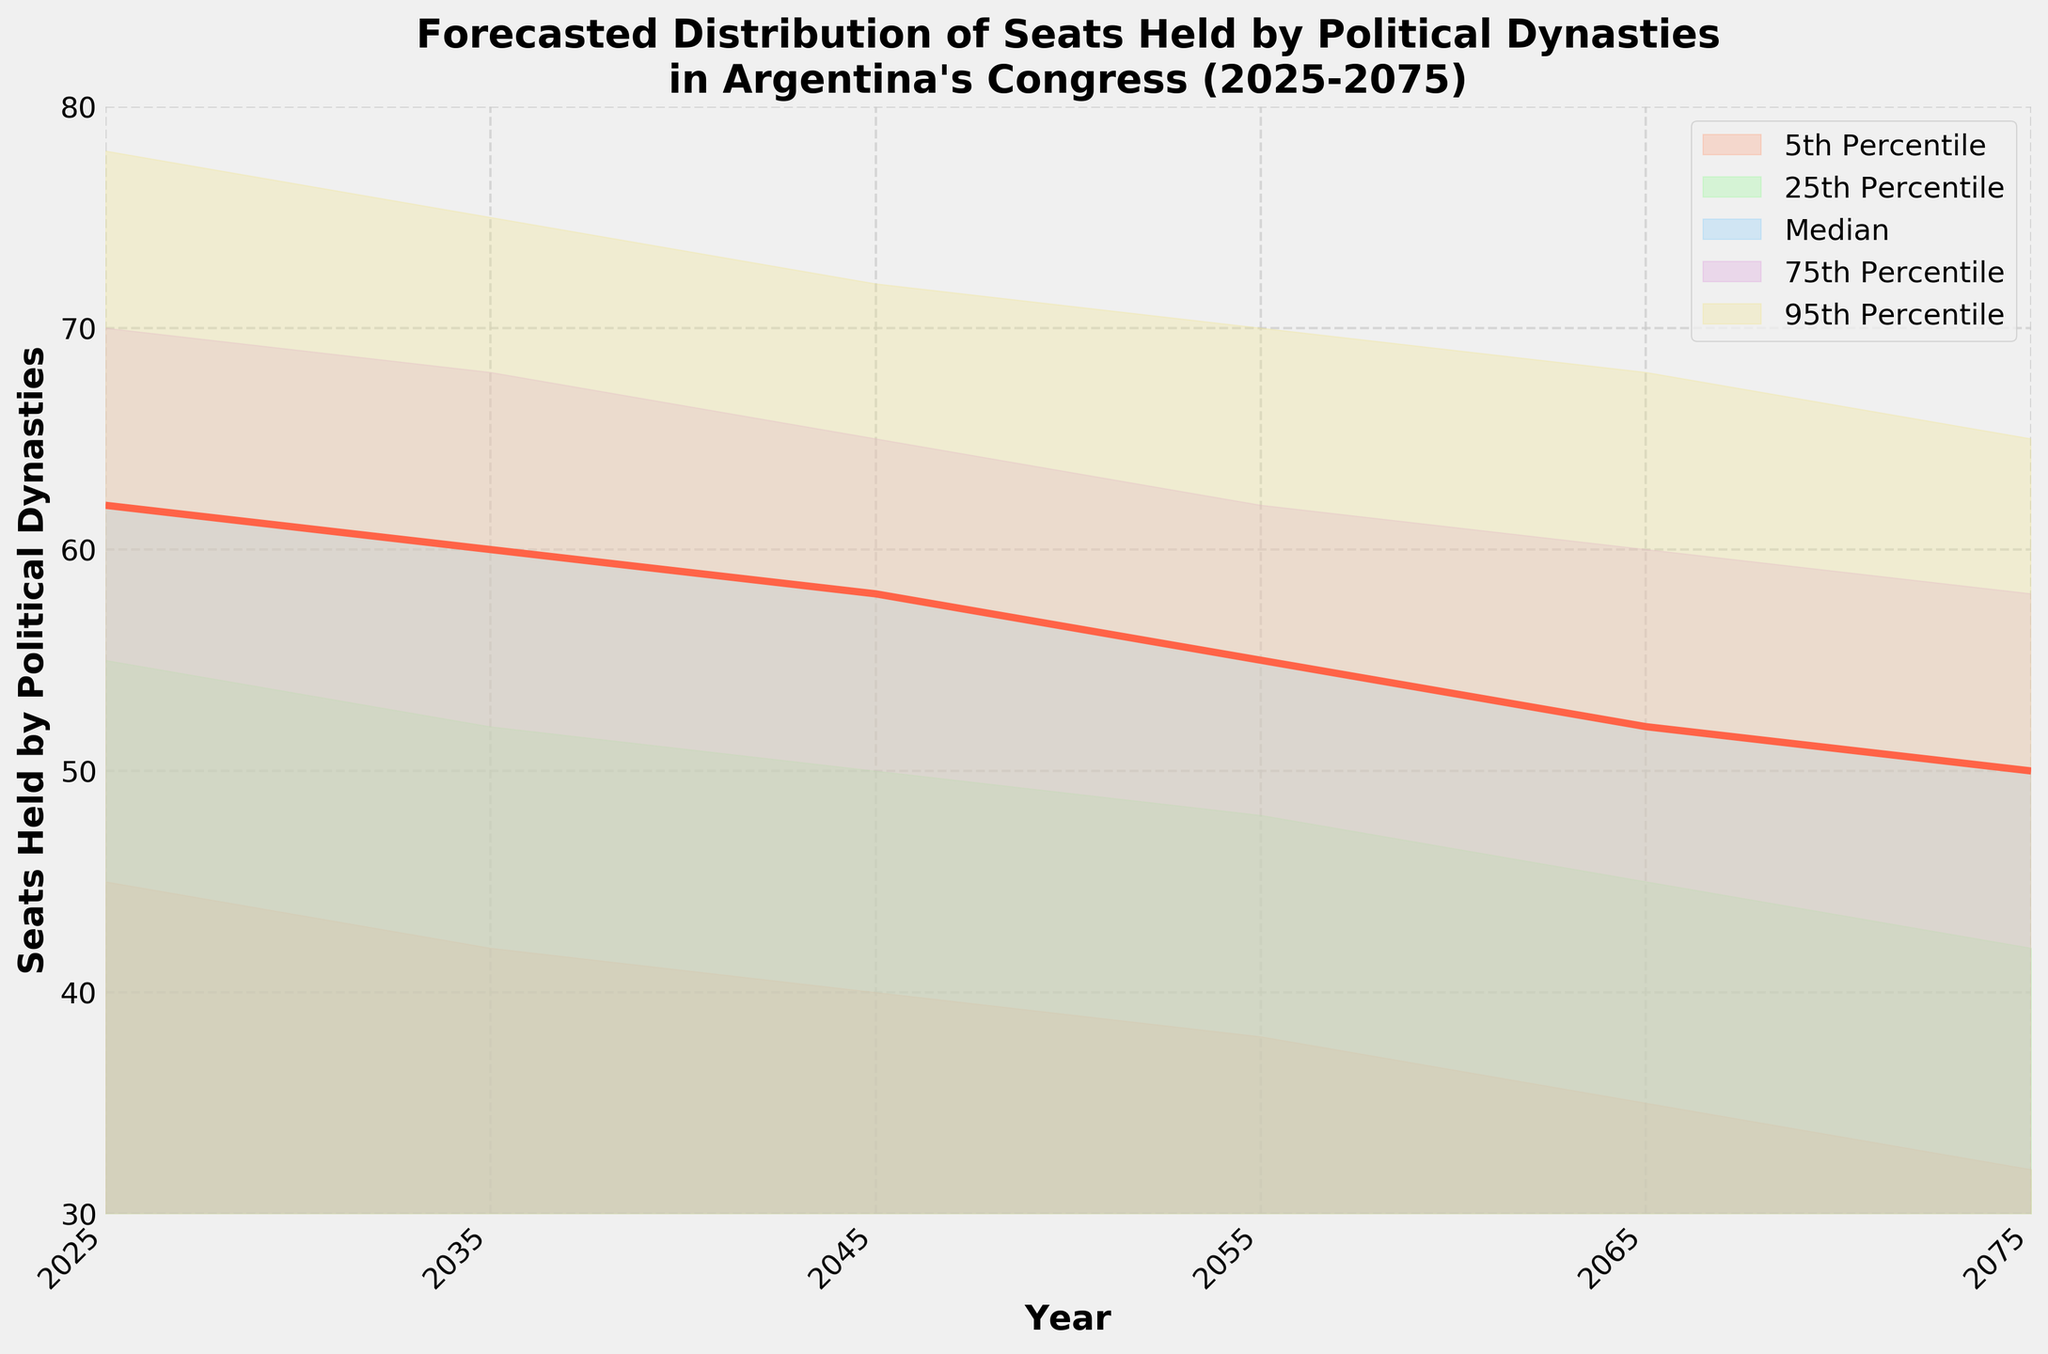What is the title of the figure? The title is usually located at the top of the plot and describes the content being presented. Here, the title shows that the figure is about projecting the number of seats held by political dynasties in Argentina's Congress over several decades.
Answer: Forecasted Distribution of Seats Held by Political Dynasties in Argentina's Congress (2025-2075) What does the y-axis represent? The y-axis typically represents the measurement being plotted. In this figure, it represents the number of seats held by political dynasties in Argentina's Congress.
Answer: Seats Held by Political Dynasties Which color is used to represent the median forecast? In the figure, the median forecast is depicted by a specific color to differentiate it from other percentiles. Here, it is shown in red, making it easy to identify.
Answer: Red What is the median number of seats predicted for the year 2045? The median line provides the central forecast for each year. To find the median number of seats for 2045, locate the median line on the y-axis corresponding to the year 2045.
Answer: 58 How does the range between the 5th and 95th percentiles change from 2025 to 2075? To determine the range, subtract the 5th percentile value from the 95th percentile value for each year and then compare these ranges.
Answer: It decreases from 33 to 33 seats In which year is the median number of seats forecasted to be 52? Look for the year where the median forecast (red line) intersects with the y-axis value of 52 seats.
Answer: 2065 By how much does the median forecast change between 2025 and 2075? Subtract the median value for 2075 from that for 2025 to find the difference.
Answer: 12 seats decrease How does the forecasted number of seats at the 25th percentile compare between 2035 and 2045? Compare the 25th percentile values for the two years by checking the corresponding y-axis values.
Answer: It decreases from 52 to 50 seats What is the range of forecasted seats in 2055 for the middle 50 percent (25th to 75th percentile)? The range for the middle 50 percent is found by subtracting the 25th percentile value from the 75th percentile value for the year 2055.
Answer: 14 seats In which decade does the model predict the steepest decline in the median number of seats? Identify the decade with the largest decrease in the median forecast by comparing the values at the start and end of each decade.
Answer: 2025-2035 